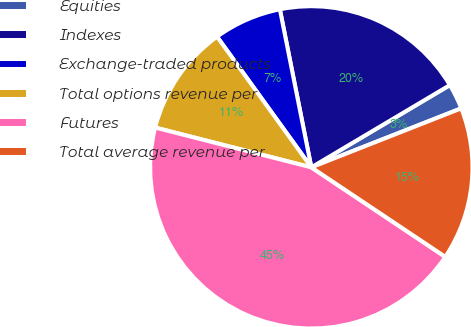Convert chart to OTSL. <chart><loc_0><loc_0><loc_500><loc_500><pie_chart><fcel>Equities<fcel>Indexes<fcel>Exchange-traded products<fcel>Total options revenue per<fcel>Futures<fcel>Total average revenue per<nl><fcel>2.56%<fcel>19.6%<fcel>6.82%<fcel>11.08%<fcel>44.6%<fcel>15.34%<nl></chart> 